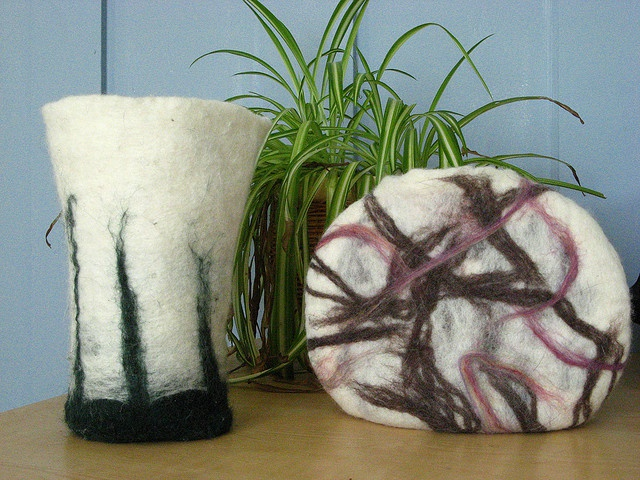Describe the objects in this image and their specific colors. I can see potted plant in darkgray, black, and darkgreen tones, vase in darkgray, gray, lightgray, and black tones, and vase in darkgray, beige, and black tones in this image. 